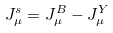Convert formula to latex. <formula><loc_0><loc_0><loc_500><loc_500>J _ { \mu } ^ { s } = J _ { \mu } ^ { B } - J _ { \mu } ^ { Y }</formula> 